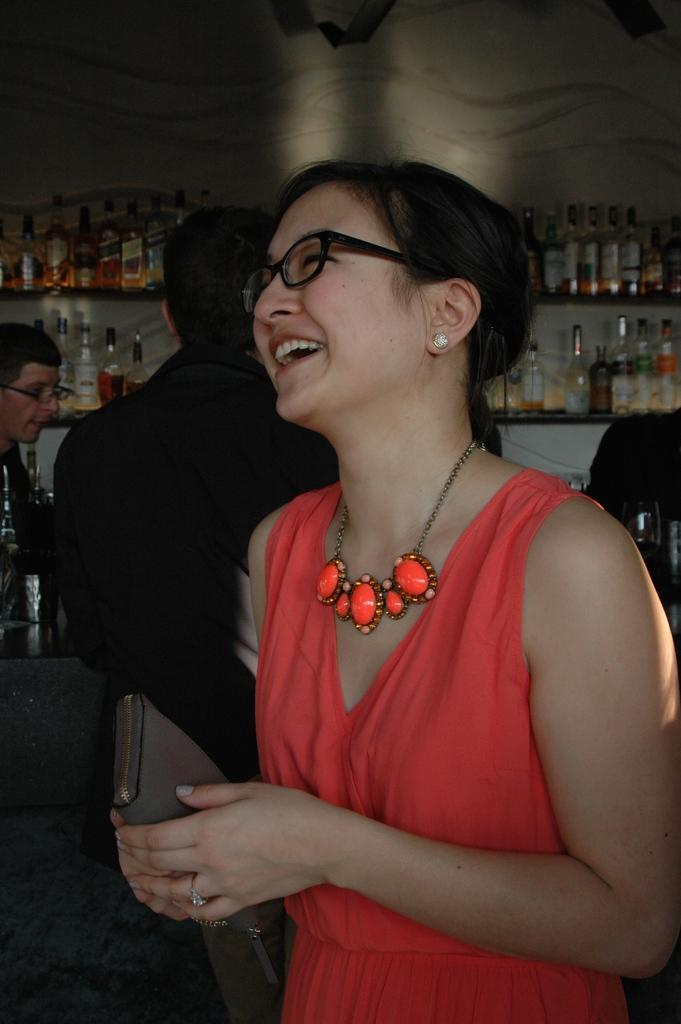What is the main subject of the image? The main subject of the image is a group of people. Can you describe the appearance of the people in the group? The people in the group are wearing different color dresses. Are there any specific accessories worn by some of the people? Yes, two people in the group are wearing specs. What can be seen in the background of the image? There are wine bottles on shelves in the background of the image. What type of arch can be seen in the image? There is no arch present in the image. Is there a band playing music in the image? There is no band playing music in the image. 